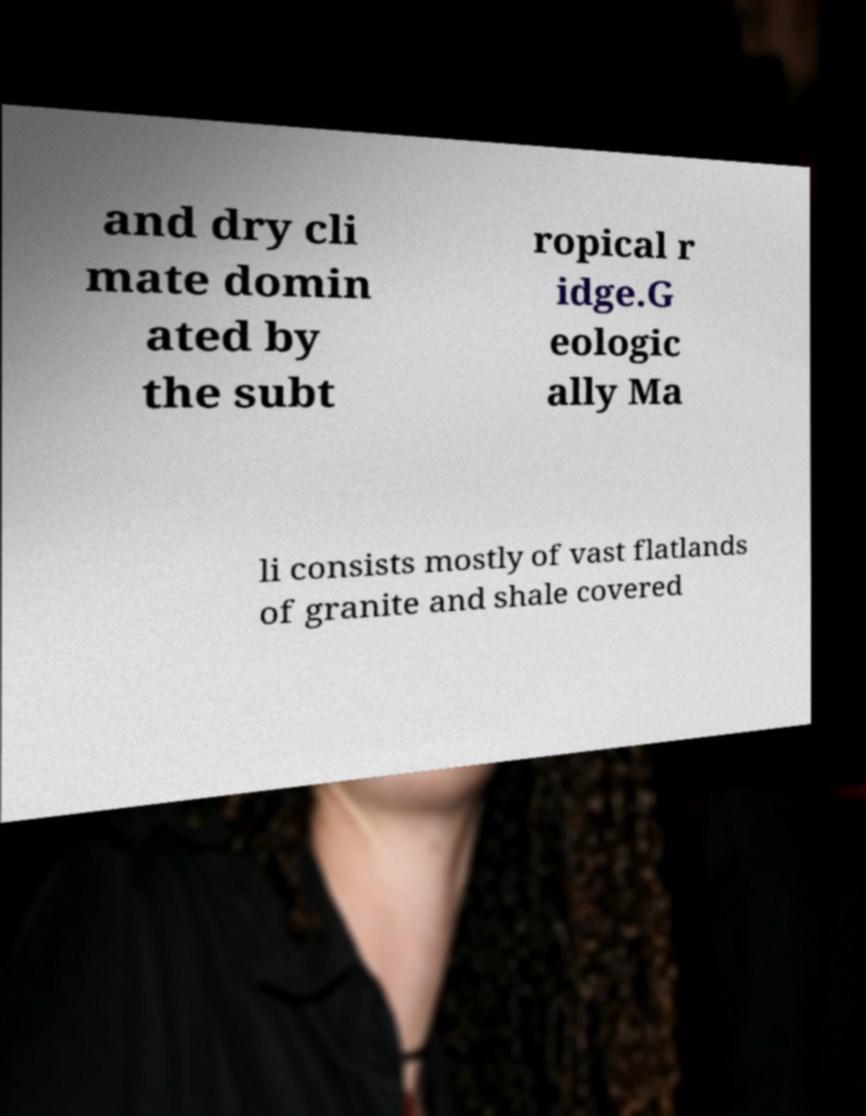There's text embedded in this image that I need extracted. Can you transcribe it verbatim? and dry cli mate domin ated by the subt ropical r idge.G eologic ally Ma li consists mostly of vast flatlands of granite and shale covered 